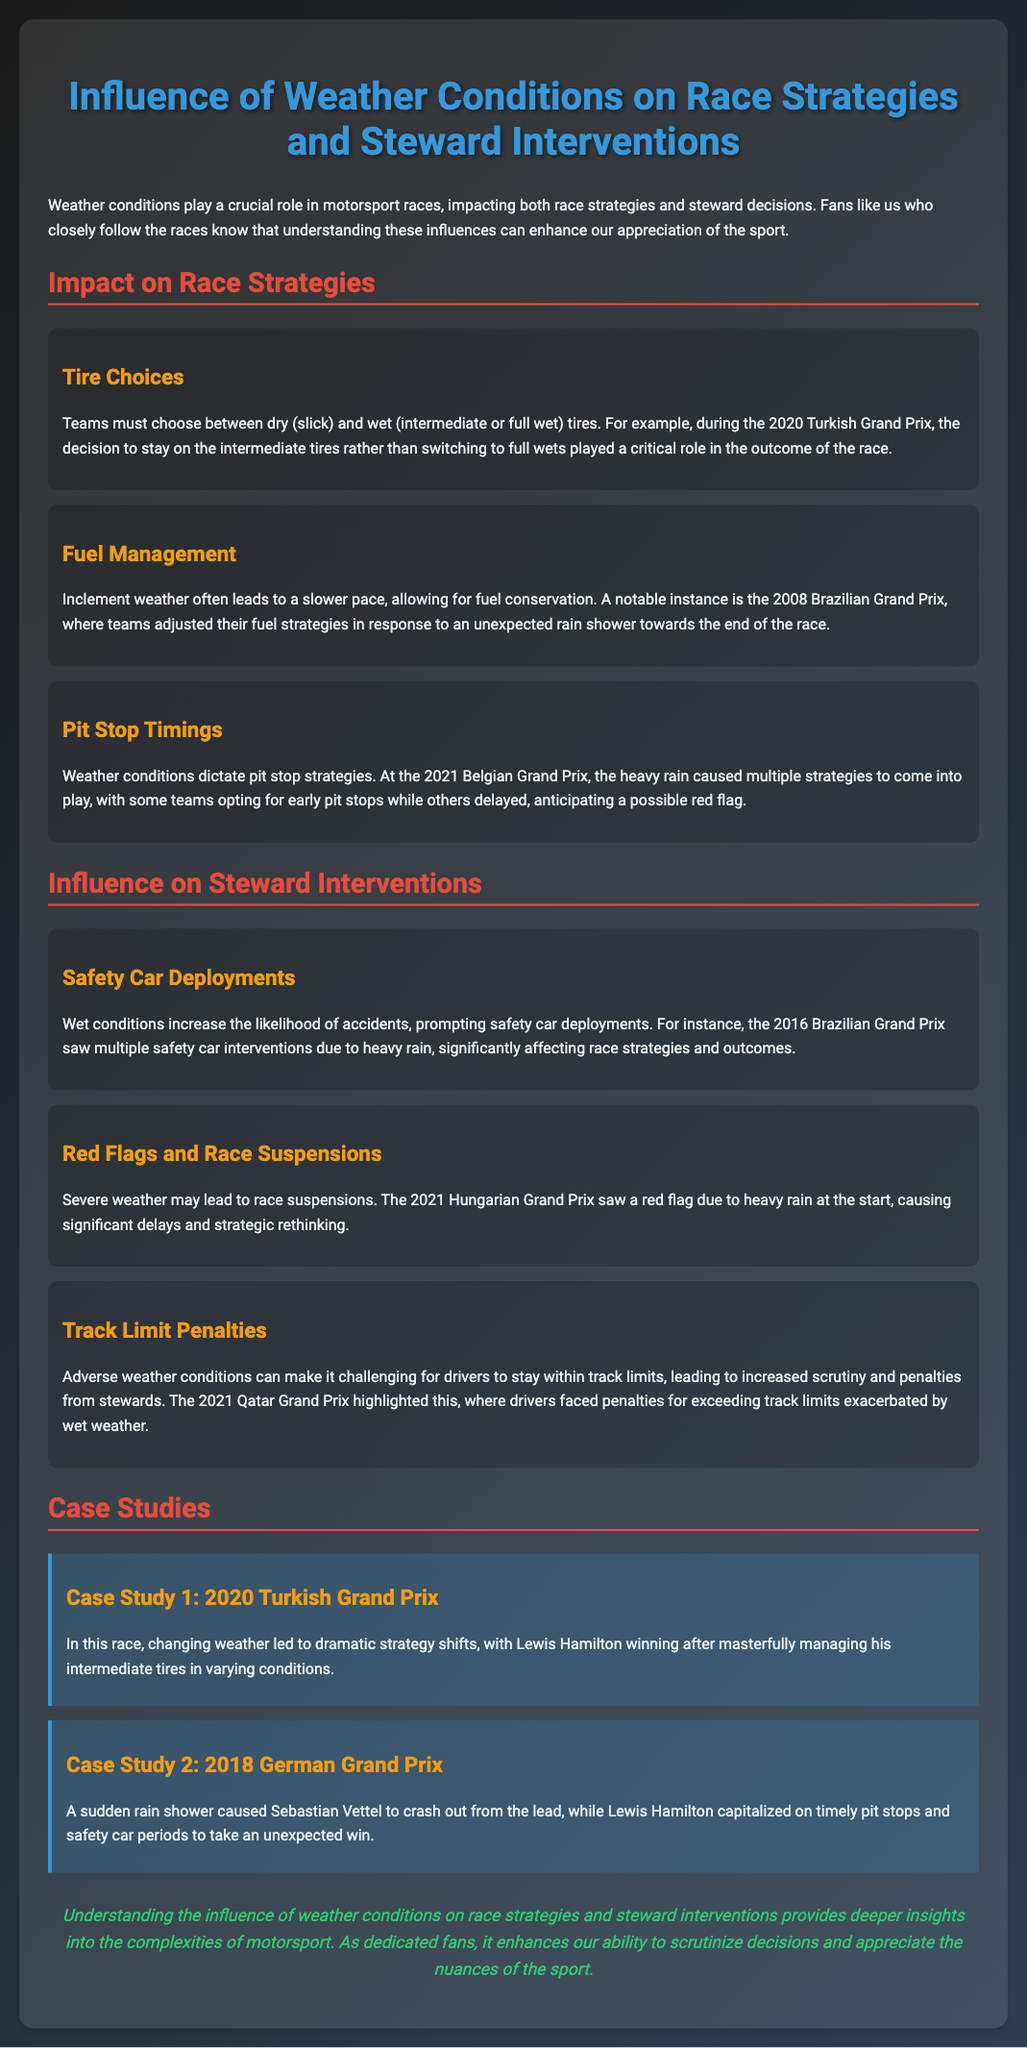What tire choice was critical during the 2020 Turkish Grand Prix? The document mentions that the decision to stay on intermediate tires rather than switching to full wets was critical during the race.
Answer: intermediate tires What event caused a red flag during the 2021 Hungarian Grand Prix? According to the slide, heavy rain at the start of the race led to the red flag.
Answer: heavy rain Which tire type allows for fuel conservation in inclement weather? The slide states that wet tires are often used in inclement weather, which allows for slower racing pace and fuel conservation.
Answer: wet tires What major incident occurred during the 2018 German Grand Prix? The document describes that a sudden rain shower caused Sebastian Vettel to crash out from the lead.
Answer: Sebastian Vettel's crash How did the 2021 Belgian Grand Prix participants differ in their pit stop strategies? The slide indicates that teams had varying strategies, with some opting for early pit stops and others delaying, anticipating a possible red flag.
Answer: varying strategies What conclusion can fans draw about weather's impact on motorsport? The conclusion of the slide emphasizes that understanding weather's influence provides deeper insights into the complexities of the sport.
Answer: deeper insights What safety measure is more likely to be deployed in wet conditions? The document states that wet conditions increase the likelihood of safety car deployments.
Answer: safety car deployments Which driver won the 2020 Turkish Grand Prix? The case study section notes that Lewis Hamilton won the 2020 Turkish Grand Prix after managing his intermediate tires well.
Answer: Lewis Hamilton 